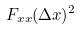Convert formula to latex. <formula><loc_0><loc_0><loc_500><loc_500>F _ { x x } ( \Delta x ) ^ { 2 }</formula> 